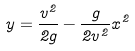Convert formula to latex. <formula><loc_0><loc_0><loc_500><loc_500>y = \frac { v ^ { 2 } } { 2 g } - \frac { g } { 2 v ^ { 2 } } x ^ { 2 }</formula> 